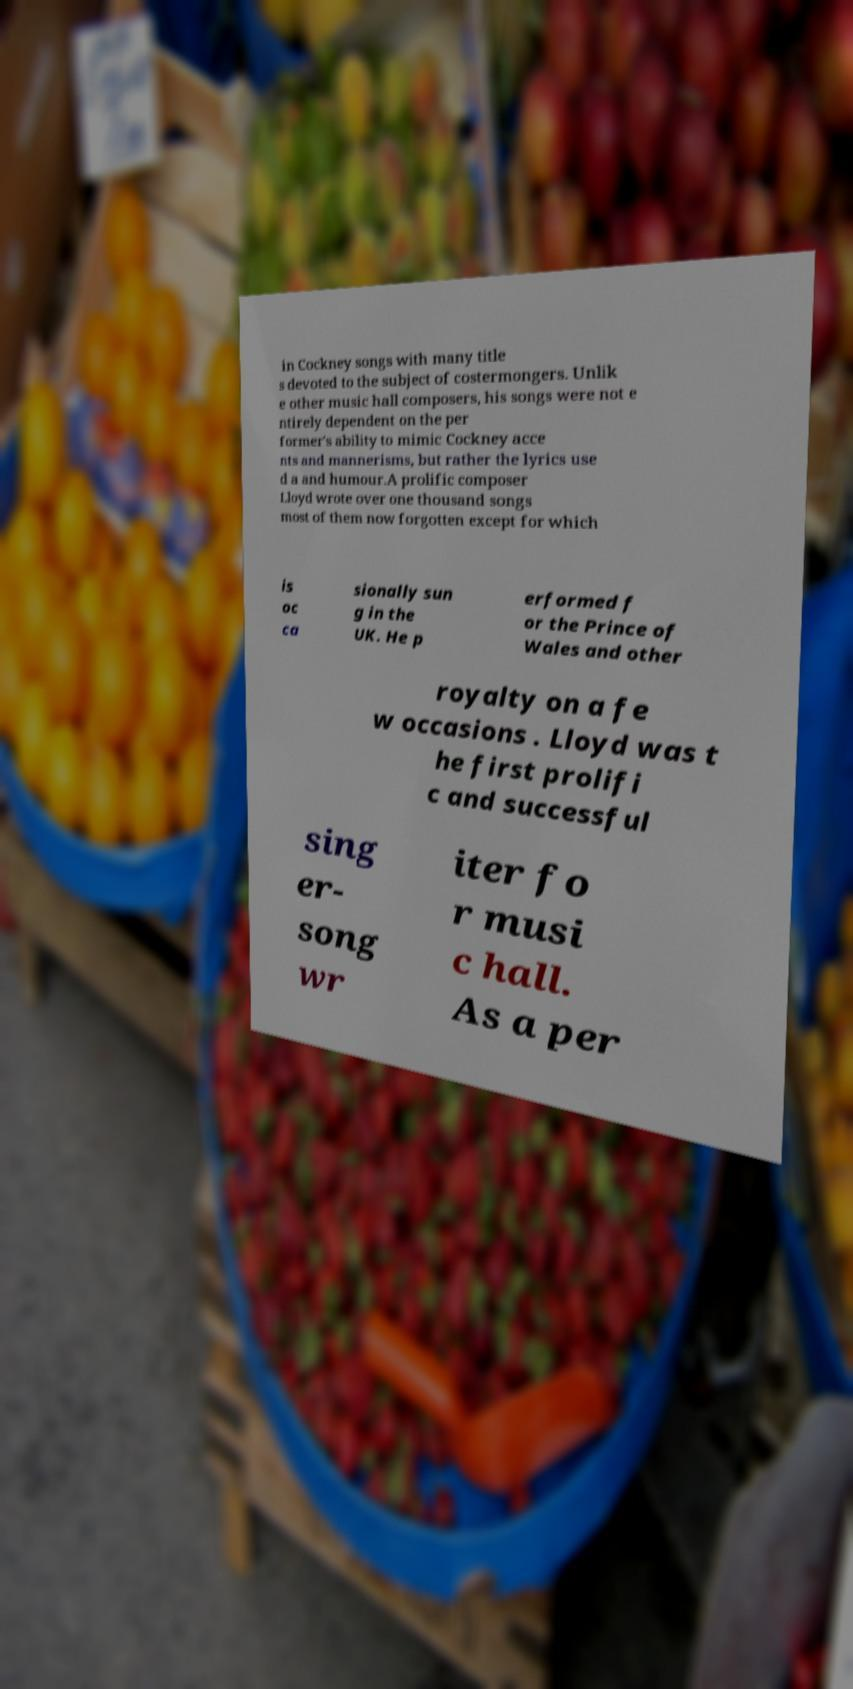Please identify and transcribe the text found in this image. in Cockney songs with many title s devoted to the subject of costermongers. Unlik e other music hall composers, his songs were not e ntirely dependent on the per former's ability to mimic Cockney acce nts and mannerisms, but rather the lyrics use d a and humour.A prolific composer Lloyd wrote over one thousand songs most of them now forgotten except for which is oc ca sionally sun g in the UK. He p erformed f or the Prince of Wales and other royalty on a fe w occasions . Lloyd was t he first prolifi c and successful sing er- song wr iter fo r musi c hall. As a per 